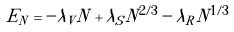<formula> <loc_0><loc_0><loc_500><loc_500>E _ { N } = - \lambda _ { V } N + \lambda _ { S } N ^ { 2 / 3 } - \lambda _ { R } N ^ { 1 / 3 }</formula> 